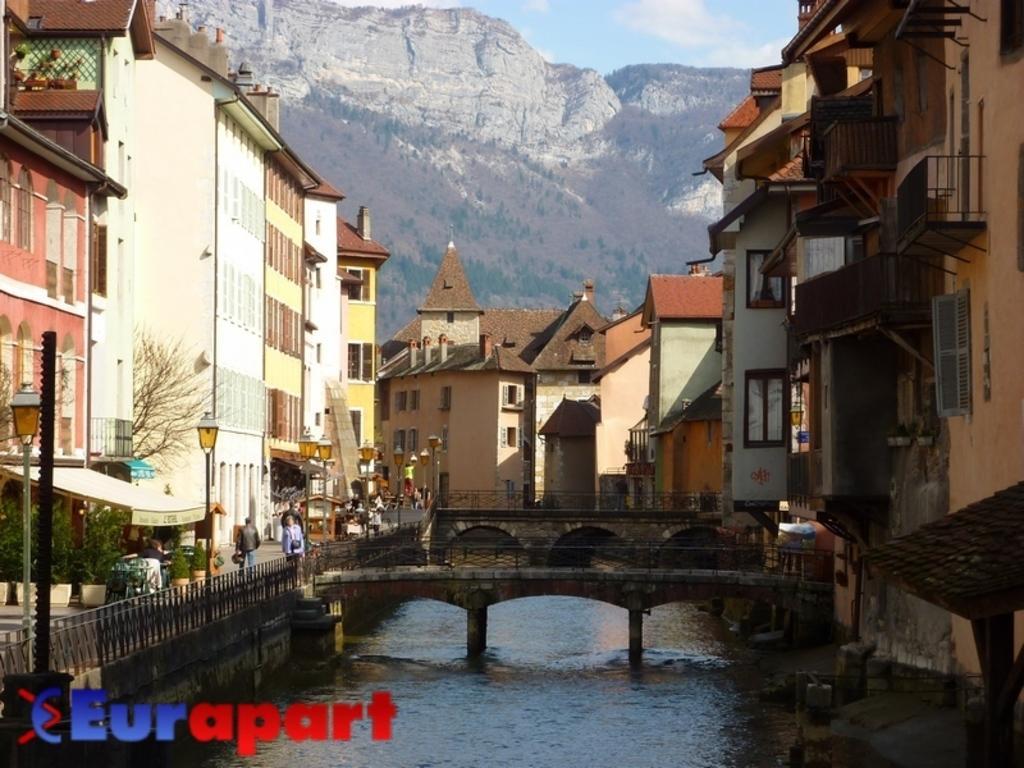Can you describe this image briefly? In this image, we can see a bridge and in the background, there are trees and buildings. At the top, there is a mountain and at the bottom, there is water and we can see some people walking on the road. 